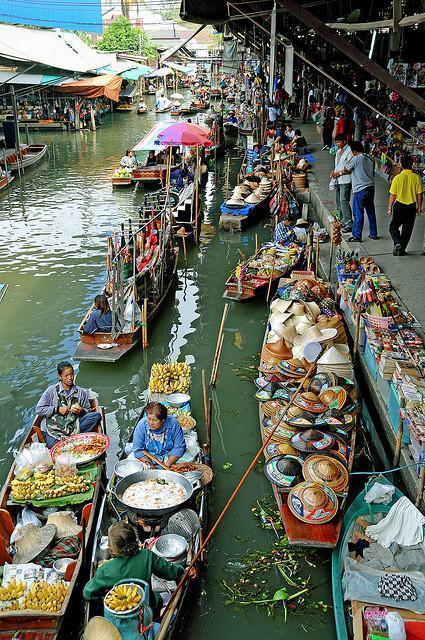What are on some of the boats?
Select the correct answer and articulate reasoning with the following format: 'Answer: answer
Rationale: rationale.'
Options: Cows, cats, bananas, surfboards. Answer: bananas.
Rationale: You can tell by the color and the market setting as to what is on the boats. 